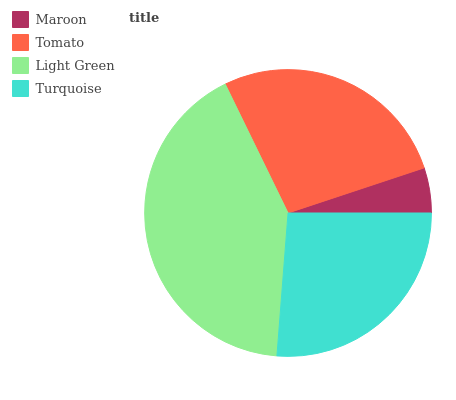Is Maroon the minimum?
Answer yes or no. Yes. Is Light Green the maximum?
Answer yes or no. Yes. Is Tomato the minimum?
Answer yes or no. No. Is Tomato the maximum?
Answer yes or no. No. Is Tomato greater than Maroon?
Answer yes or no. Yes. Is Maroon less than Tomato?
Answer yes or no. Yes. Is Maroon greater than Tomato?
Answer yes or no. No. Is Tomato less than Maroon?
Answer yes or no. No. Is Tomato the high median?
Answer yes or no. Yes. Is Turquoise the low median?
Answer yes or no. Yes. Is Turquoise the high median?
Answer yes or no. No. Is Light Green the low median?
Answer yes or no. No. 